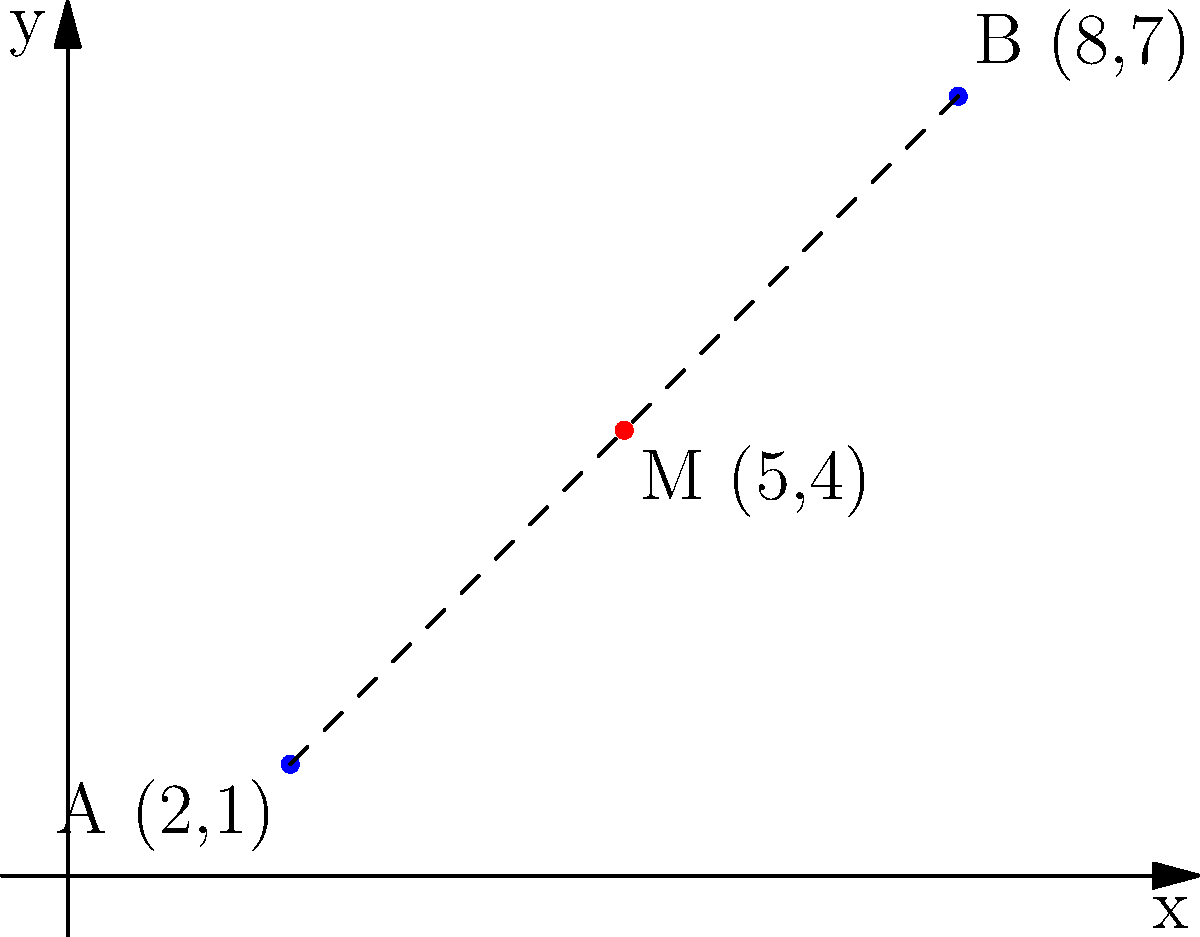In a recent archaeological study in the Czech Republic, two significant Neolithic sites were discovered. Site A is located at coordinates (2,1) and site B at (8,7) on a coordinate grid where each unit represents 1 kilometer. Find the coordinates of point M, which is the midpoint of the line segment connecting these two sites. How might this midpoint be significant in understanding the spatial relationships between these ancient settlements? To find the midpoint M of the line segment connecting points A(2,1) and B(8,7), we can use the midpoint formula:

$$ M = (\frac{x_1 + x_2}{2}, \frac{y_1 + y_2}{2}) $$

Where $(x_1, y_1)$ are the coordinates of point A, and $(x_2, y_2)$ are the coordinates of point B.

Step 1: Calculate the x-coordinate of the midpoint:
$$ x_M = \frac{x_1 + x_2}{2} = \frac{2 + 8}{2} = \frac{10}{2} = 5 $$

Step 2: Calculate the y-coordinate of the midpoint:
$$ y_M = \frac{y_1 + y_2}{2} = \frac{1 + 7}{2} = \frac{8}{2} = 4 $$

Therefore, the coordinates of the midpoint M are (5,4).

The significance of this midpoint in understanding the spatial relationships between these ancient settlements could be:

1. It may indicate a potential area for further archaeological investigation, as it could represent a central point between the two sites.
2. It could suggest a possible trade route or communication line between the two settlements.
3. The midpoint might represent a shared resource area or a neutral meeting ground for the inhabitants of both sites.
4. Understanding the midpoint's location in relation to geographical features (rivers, hills, etc.) could provide insights into why these particular locations were chosen for settlement.
Answer: M(5,4) 